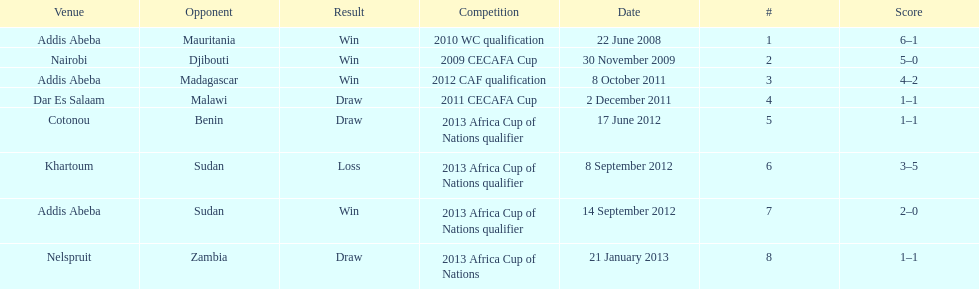What date gives was their only loss? 8 September 2012. 